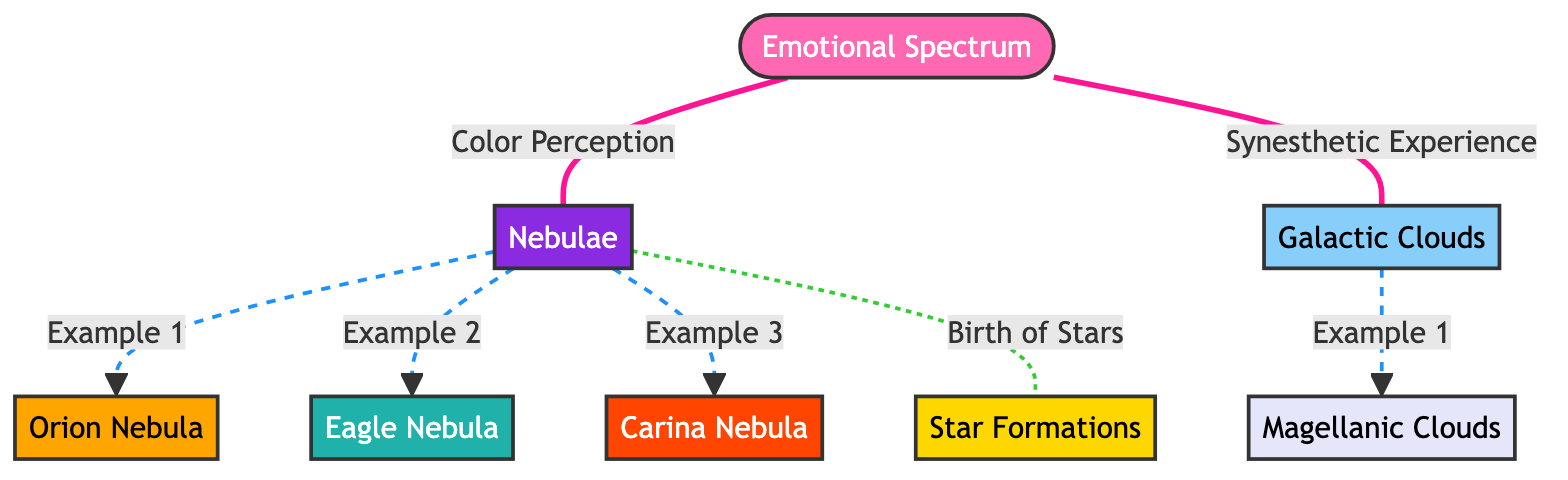What are the colors representing nebulae? In the diagram, nebulae are represented by the color deep blue violet (hex code: #8A2BE2). This color is visually distinct and is used specifically to classify nebulae in the emotional spectrum context.
Answer: deep blue violet How many examples of nebulae are listed? There are three examples of nebulae provided in the diagram: Orion Nebula, Eagle Nebula, and Carina Nebula. To arrive at this answer, one simply counts the listed nebulae connected to the nebulae node.
Answer: 3 What is the color assigned to the Galactic Clouds? The color assigned to the Galactic Clouds is light sky blue (hex code: #87CEFA). This can be found by examining the class definition associated with the galactic_clouds node.
Answer: light sky blue Which nebula is associated with star formations? The diagram indicates that nebulae connect to star formations, and upon deeper inspection, it can be concluded that nebulae generally are involved in star formation, making star formations specifically linked to nebulae in general.
Answer: Star Formations How are the relationships between emotional spectrum and nebulae structured? The emotional spectrum shows a connection to nebulae through the phrase "Color Perception," meaning that nebulae are linked to the emotional spectrum by the specific colors that represent their perceived emotional attributes.
Answer: Color Perception What type of lines connect nebulae to their examples? The examples of nebulae (Orion Nebula, Eagle Nebula, Carina Nebula) are connected with dashed lines, indicating distinct examples or relationships rather than direct connections. The line style clearly identifies them as examples.
Answer: Dashed lines How many different types of celestial phenomena are represented in the diagram? The diagram shows four different types of celestial phenomena: Nebulae, Galactic Clouds, Star Formations, and a specific emotional spectrum associated with them. This is derived from counting the unique nodes in the diagram.
Answer: 4 What is the color used for the Emotional Spectrum? The Emotional Spectrum in the diagram is represented by the color hot pink (hex code: #FF69B4). This color encodes the emotional attributes associated with celestial observations in this context.
Answer: hot pink 